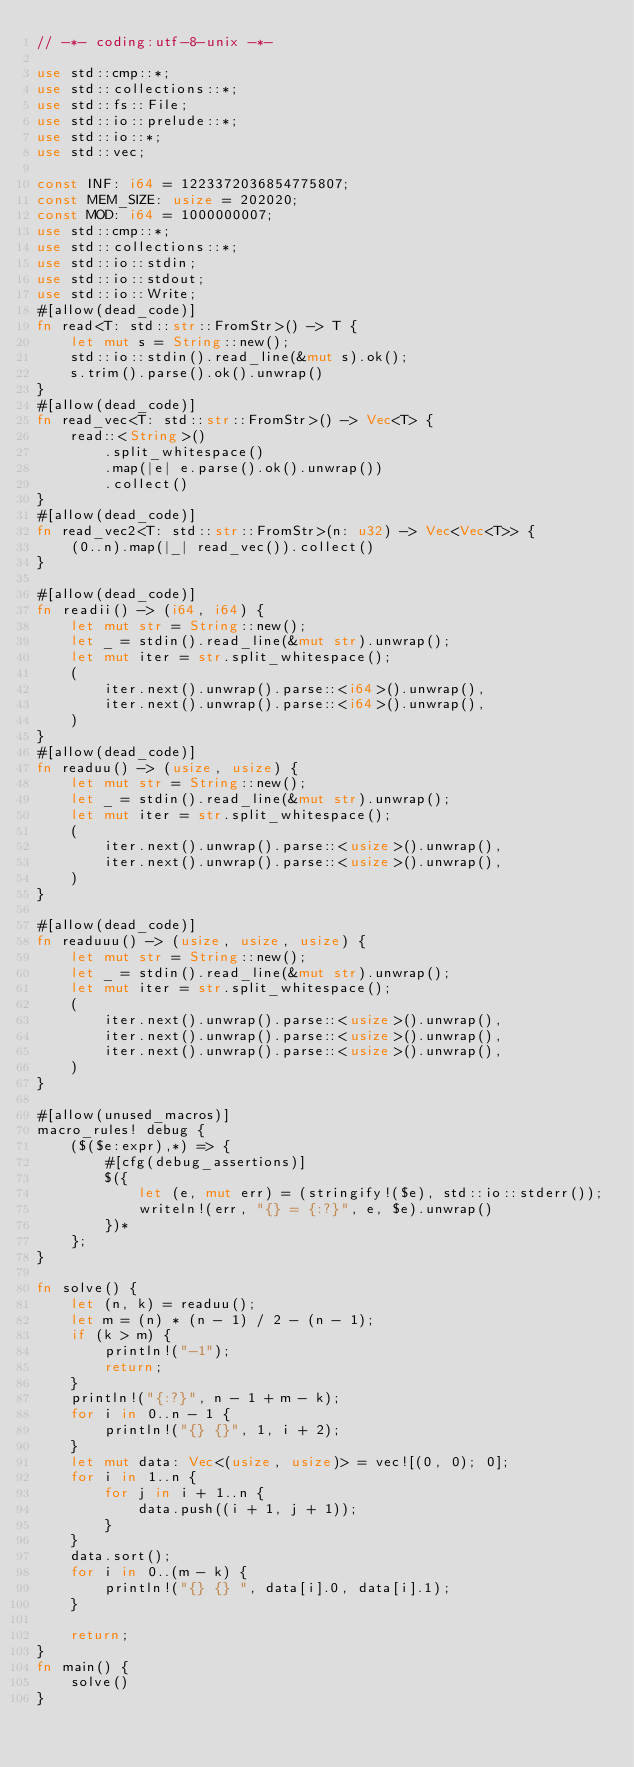Convert code to text. <code><loc_0><loc_0><loc_500><loc_500><_Rust_>// -*- coding:utf-8-unix -*-

use std::cmp::*;
use std::collections::*;
use std::fs::File;
use std::io::prelude::*;
use std::io::*;
use std::vec;

const INF: i64 = 1223372036854775807;
const MEM_SIZE: usize = 202020;
const MOD: i64 = 1000000007;
use std::cmp::*;
use std::collections::*;
use std::io::stdin;
use std::io::stdout;
use std::io::Write;
#[allow(dead_code)]
fn read<T: std::str::FromStr>() -> T {
    let mut s = String::new();
    std::io::stdin().read_line(&mut s).ok();
    s.trim().parse().ok().unwrap()
}
#[allow(dead_code)]
fn read_vec<T: std::str::FromStr>() -> Vec<T> {
    read::<String>()
        .split_whitespace()
        .map(|e| e.parse().ok().unwrap())
        .collect()
}
#[allow(dead_code)]
fn read_vec2<T: std::str::FromStr>(n: u32) -> Vec<Vec<T>> {
    (0..n).map(|_| read_vec()).collect()
}

#[allow(dead_code)]
fn readii() -> (i64, i64) {
    let mut str = String::new();
    let _ = stdin().read_line(&mut str).unwrap();
    let mut iter = str.split_whitespace();
    (
        iter.next().unwrap().parse::<i64>().unwrap(),
        iter.next().unwrap().parse::<i64>().unwrap(),
    )
}
#[allow(dead_code)]
fn readuu() -> (usize, usize) {
    let mut str = String::new();
    let _ = stdin().read_line(&mut str).unwrap();
    let mut iter = str.split_whitespace();
    (
        iter.next().unwrap().parse::<usize>().unwrap(),
        iter.next().unwrap().parse::<usize>().unwrap(),
    )
}

#[allow(dead_code)]
fn readuuu() -> (usize, usize, usize) {
    let mut str = String::new();
    let _ = stdin().read_line(&mut str).unwrap();
    let mut iter = str.split_whitespace();
    (
        iter.next().unwrap().parse::<usize>().unwrap(),
        iter.next().unwrap().parse::<usize>().unwrap(),
        iter.next().unwrap().parse::<usize>().unwrap(),
    )
}

#[allow(unused_macros)]
macro_rules! debug {
    ($($e:expr),*) => {
        #[cfg(debug_assertions)]
        $({
            let (e, mut err) = (stringify!($e), std::io::stderr());
            writeln!(err, "{} = {:?}", e, $e).unwrap()
        })*
    };
}

fn solve() {
    let (n, k) = readuu();
    let m = (n) * (n - 1) / 2 - (n - 1);
    if (k > m) {
        println!("-1");
        return;
    }
    println!("{:?}", n - 1 + m - k);
    for i in 0..n - 1 {
        println!("{} {}", 1, i + 2);
    }
    let mut data: Vec<(usize, usize)> = vec![(0, 0); 0];
    for i in 1..n {
        for j in i + 1..n {
            data.push((i + 1, j + 1));
        }
    }
    data.sort();
    for i in 0..(m - k) {
        println!("{} {} ", data[i].0, data[i].1);
    }

    return;
}
fn main() {
    solve()
}
</code> 